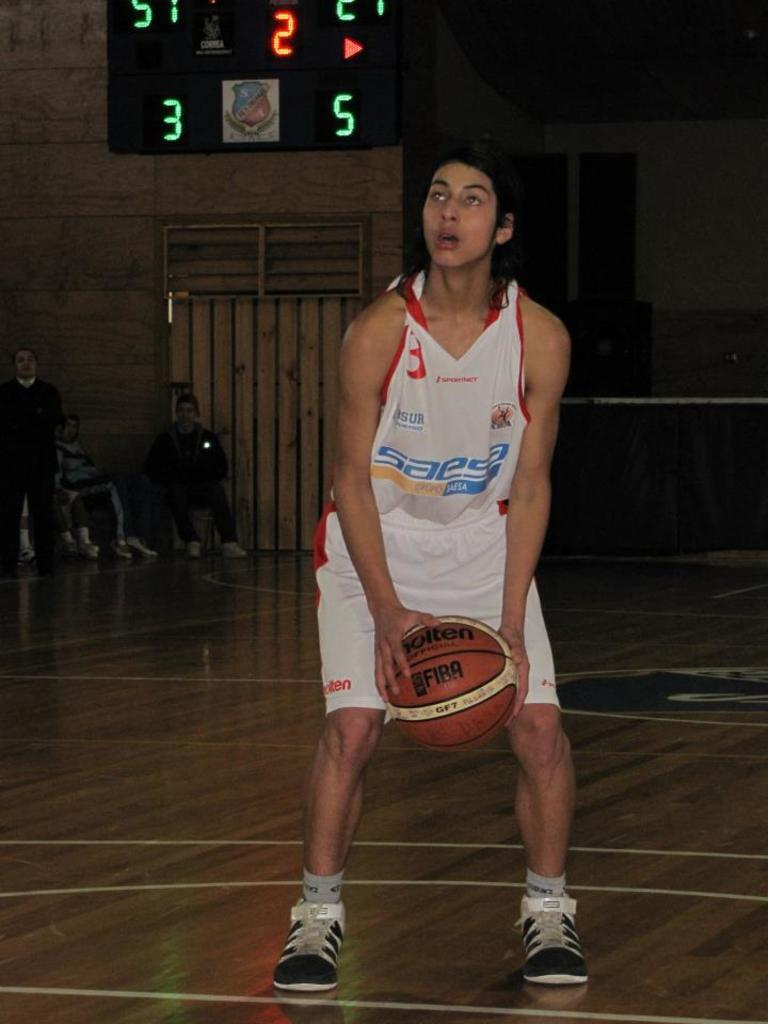<image>
Provide a brief description of the given image. Saesa is a sponsor of the basketball team. 